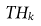Convert formula to latex. <formula><loc_0><loc_0><loc_500><loc_500>T H _ { k }</formula> 